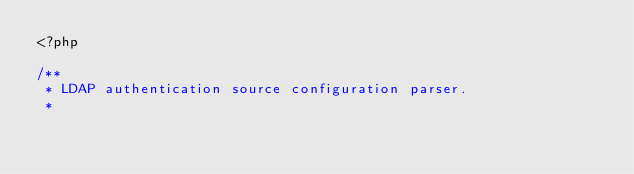Convert code to text. <code><loc_0><loc_0><loc_500><loc_500><_PHP_><?php

/**
 * LDAP authentication source configuration parser.
 *</code> 